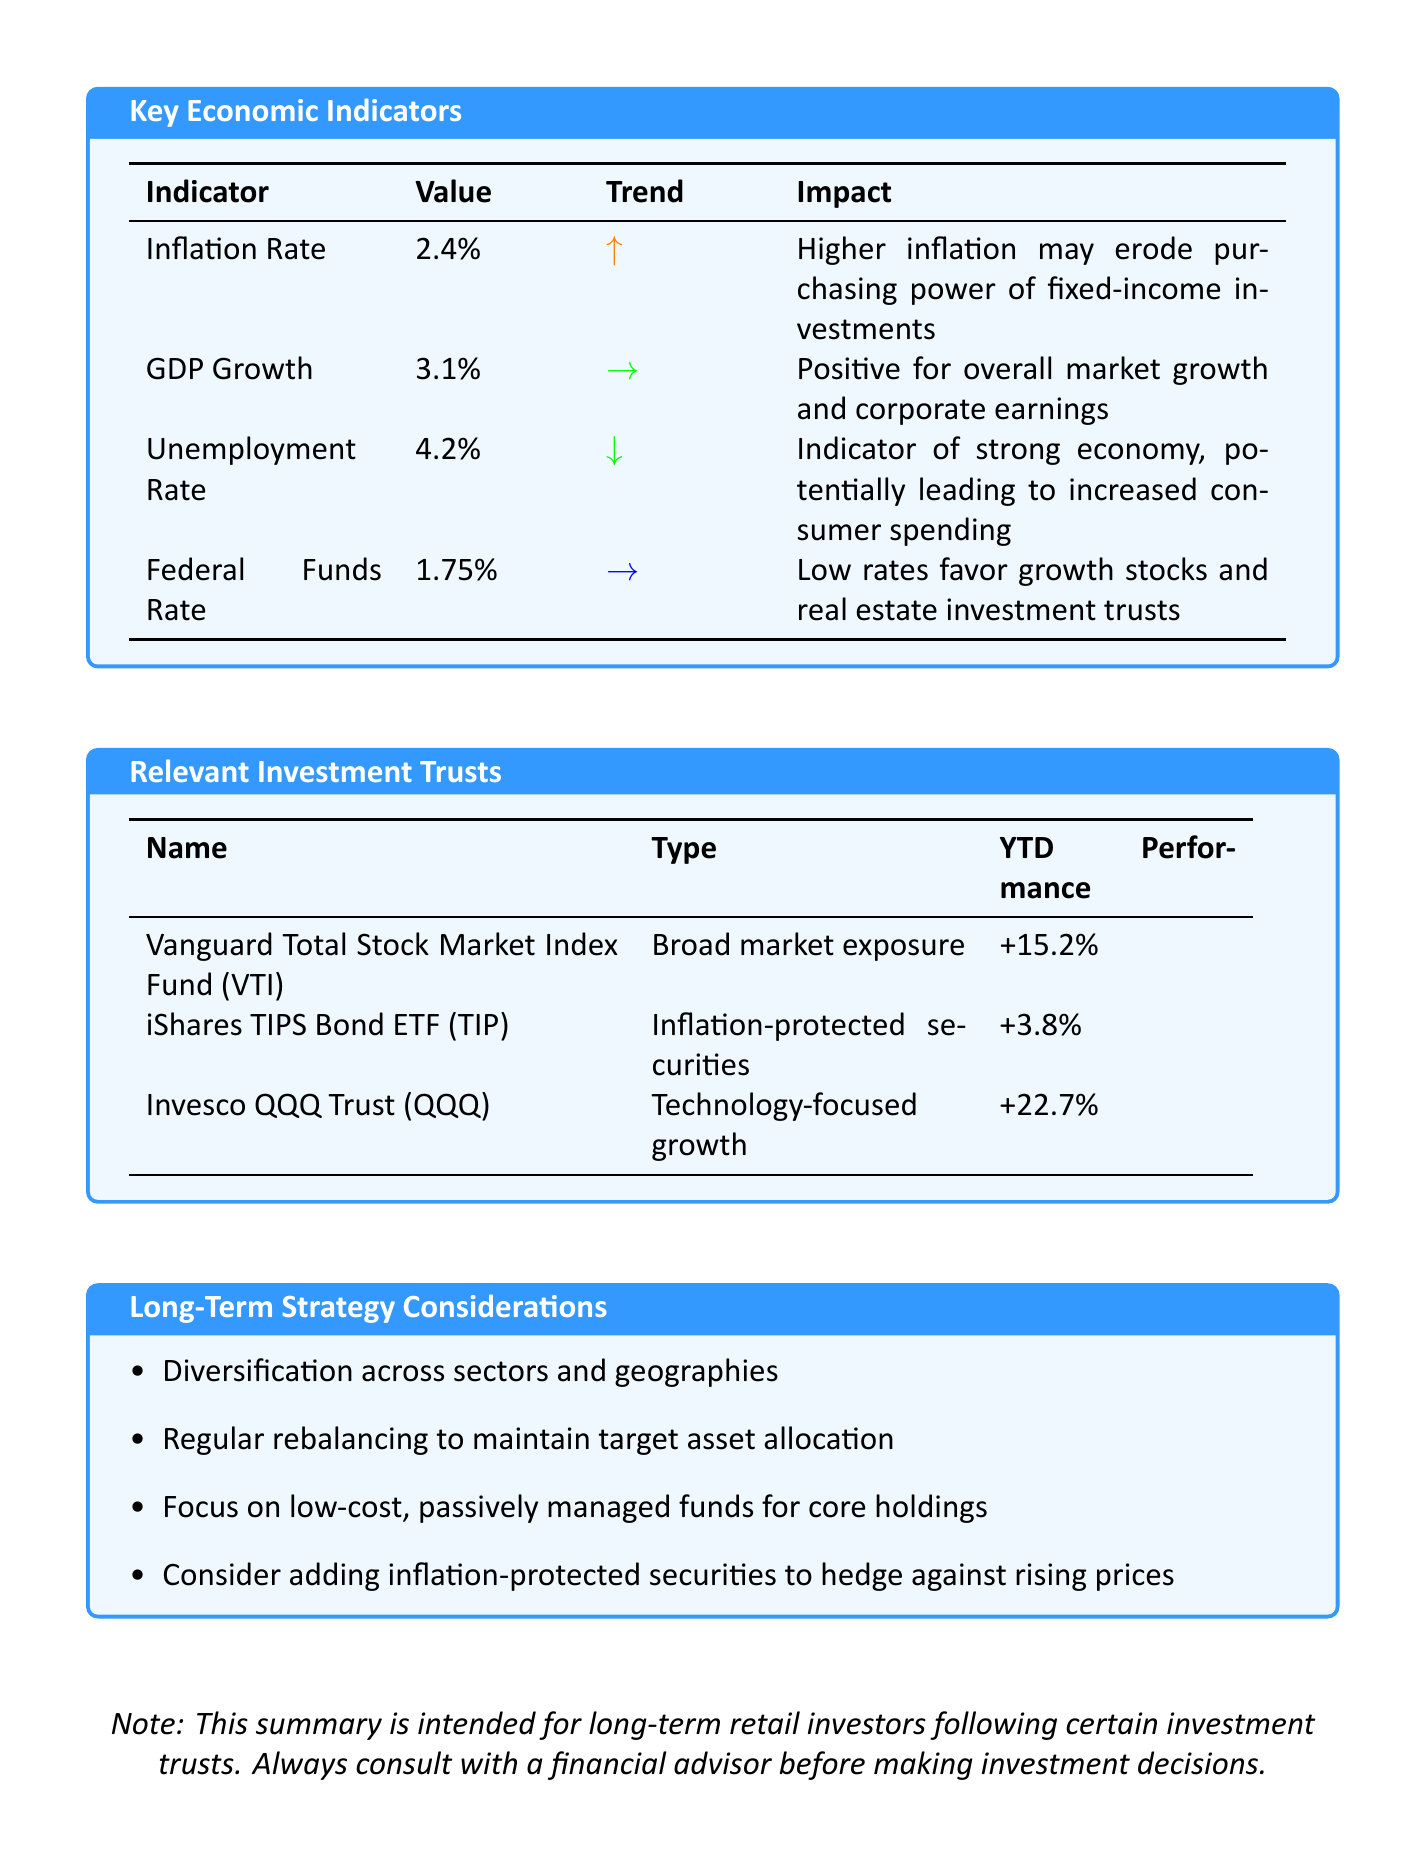What is the current inflation rate? The current inflation rate is provided in the document as a specific metric, which is 2.4%.
Answer: 2.4% What is the trend of the GDP growth? The trend of the GDP growth indicates its stability, which is mentioned as "Stable" in the document.
Answer: Stable What is the YTD performance of the Invesco QQQ Trust? The YTD performance for the Invesco QQQ Trust is indicated specifically in the document as +22.7%.
Answer: +22.7% What type of investment does the iShares TIPS Bond ETF focus on? The document categorizes the iShares TIPS Bond ETF under "Inflation-protected securities," which is its specific focus.
Answer: Inflation-protected securities How does the current unemployment rate impact consumer spending? The document states that a decreasing unemployment rate is an indicator of a strong economy, which potentially leads to increased consumer spending.
Answer: Increased consumer spending What are two long-term strategy considerations mentioned? The document lists several considerations; two of them are "Diversification across sectors and geographies" and "Regular rebalancing to maintain target asset allocation."
Answer: Diversification across sectors and geographies; Regular rebalancing to maintain target asset allocation What impact might a higher inflation rate have on fixed-income investments? According to the document, higher inflation may erode the purchasing power of fixed-income investments, which is its impact statement.
Answer: Erode purchasing power What is the current Federal Funds Rate? The current Federal Funds Rate is listed as a specific value in the document, which is 1.75%.
Answer: 1.75% 